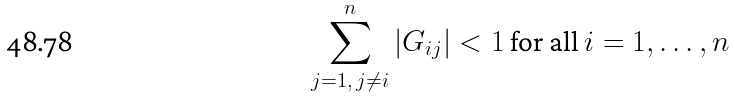<formula> <loc_0><loc_0><loc_500><loc_500>\sum _ { j = 1 , \, j \neq i } ^ { n } | G _ { i j } | < 1 \text { for all } i = 1 , \dots , n</formula> 